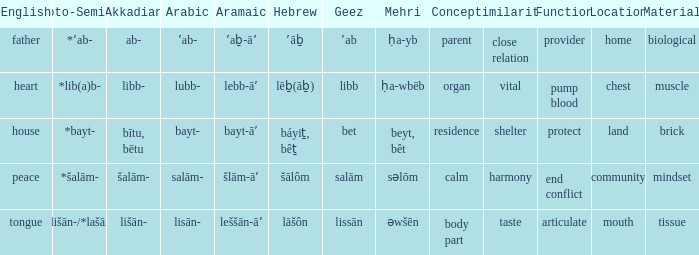What is the proto-semitic word for 'house' as it is in english? *bayt-. 